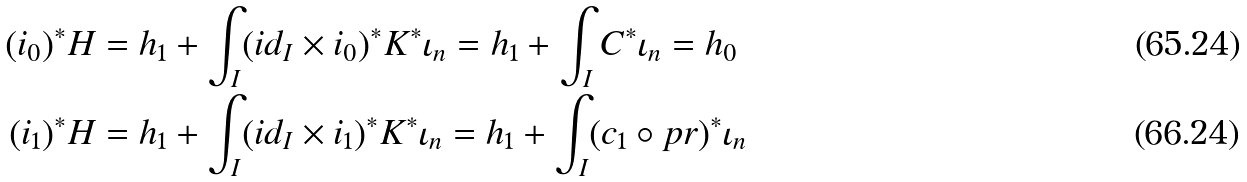Convert formula to latex. <formula><loc_0><loc_0><loc_500><loc_500>( i _ { 0 } ) ^ { * } H & = h _ { 1 } + \int _ { I } ( i d _ { I } \times i _ { 0 } ) ^ { * } K ^ { * } \iota _ { n } = h _ { 1 } + \int _ { I } C ^ { * } \iota _ { n } = h _ { 0 } \\ ( i _ { 1 } ) ^ { * } H & = h _ { 1 } + \int _ { I } ( i d _ { I } \times i _ { 1 } ) ^ { * } K ^ { * } \iota _ { n } = h _ { 1 } + \int _ { I } ( c _ { 1 } \circ p r ) ^ { * } \iota _ { n }</formula> 